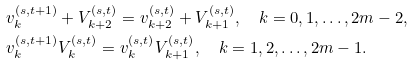Convert formula to latex. <formula><loc_0><loc_0><loc_500><loc_500>& v _ { k } ^ { ( s , t + 1 ) } + V _ { k + 2 } ^ { ( s , t ) } = v _ { k + 2 } ^ { ( s , t ) } + V _ { k + 1 } ^ { ( s , t ) } , \quad k = 0 , 1 , \dots , 2 m - 2 , \\ & v _ { k } ^ { ( s , t + 1 ) } V _ { k } ^ { ( s , t ) } = v _ { k } ^ { ( s , t ) } V _ { k + 1 } ^ { ( s , t ) } , \quad k = 1 , 2 , \dots , 2 m - 1 .</formula> 